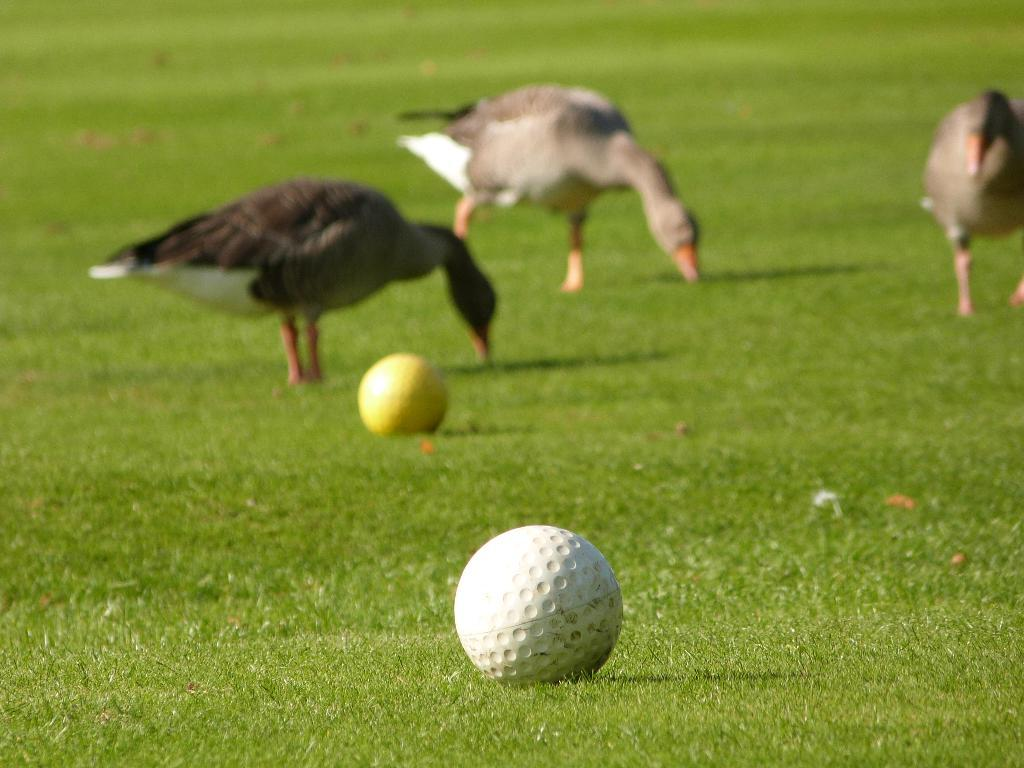What type of animals can be seen on the ground in the image? There are birds on the ground in the image. What else can be found on the ground in the image? There are balls on the ground in the image. Can you describe the terrain in the image? There is a grassy land in the image. What type of engine can be seen powering the birds in the image? There is no engine present in the image, and the birds are not being powered by any engine. 